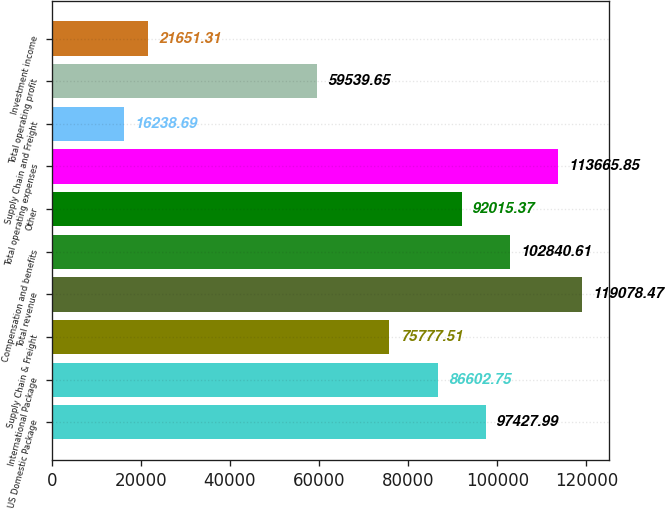Convert chart to OTSL. <chart><loc_0><loc_0><loc_500><loc_500><bar_chart><fcel>US Domestic Package<fcel>International Package<fcel>Supply Chain & Freight<fcel>Total revenue<fcel>Compensation and benefits<fcel>Other<fcel>Total operating expenses<fcel>Supply Chain and Freight<fcel>Total operating profit<fcel>Investment income<nl><fcel>97428<fcel>86602.8<fcel>75777.5<fcel>119078<fcel>102841<fcel>92015.4<fcel>113666<fcel>16238.7<fcel>59539.7<fcel>21651.3<nl></chart> 